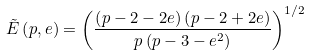Convert formula to latex. <formula><loc_0><loc_0><loc_500><loc_500>\tilde { E } \left ( p , e \right ) = \left ( \frac { \left ( p - 2 - 2 e \right ) \left ( p - 2 + 2 e \right ) } { p \left ( p - 3 - e ^ { 2 } \right ) } \right ) ^ { 1 / 2 }</formula> 